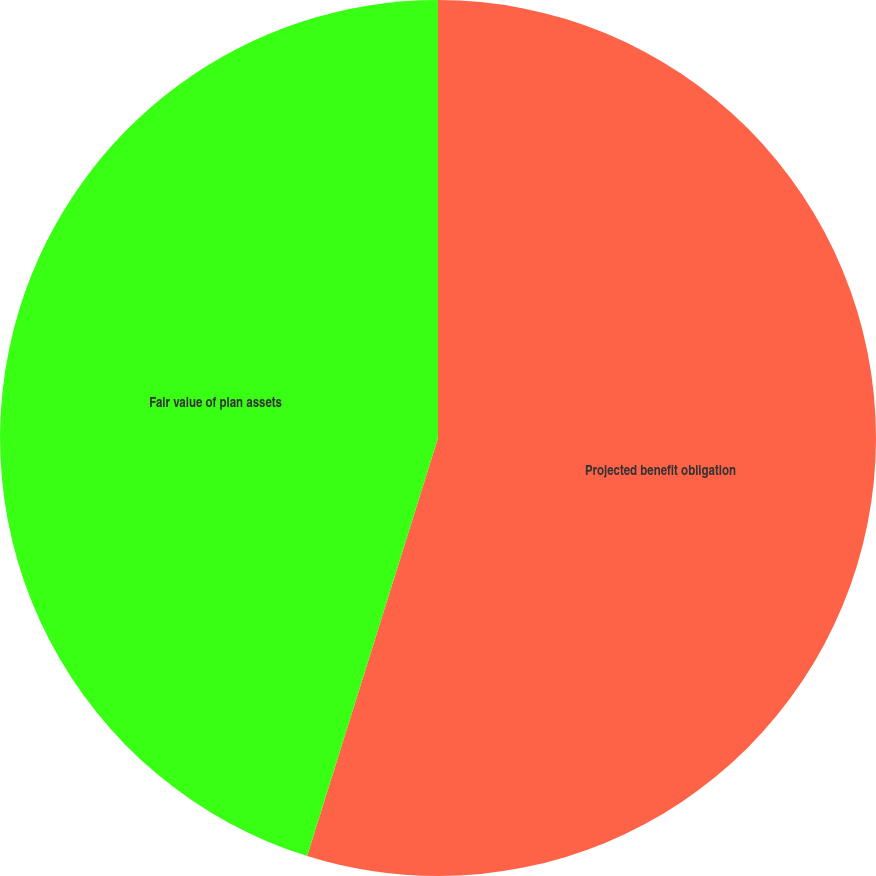Convert chart. <chart><loc_0><loc_0><loc_500><loc_500><pie_chart><fcel>Projected benefit obligation<fcel>Fair value of plan assets<nl><fcel>54.83%<fcel>45.17%<nl></chart> 